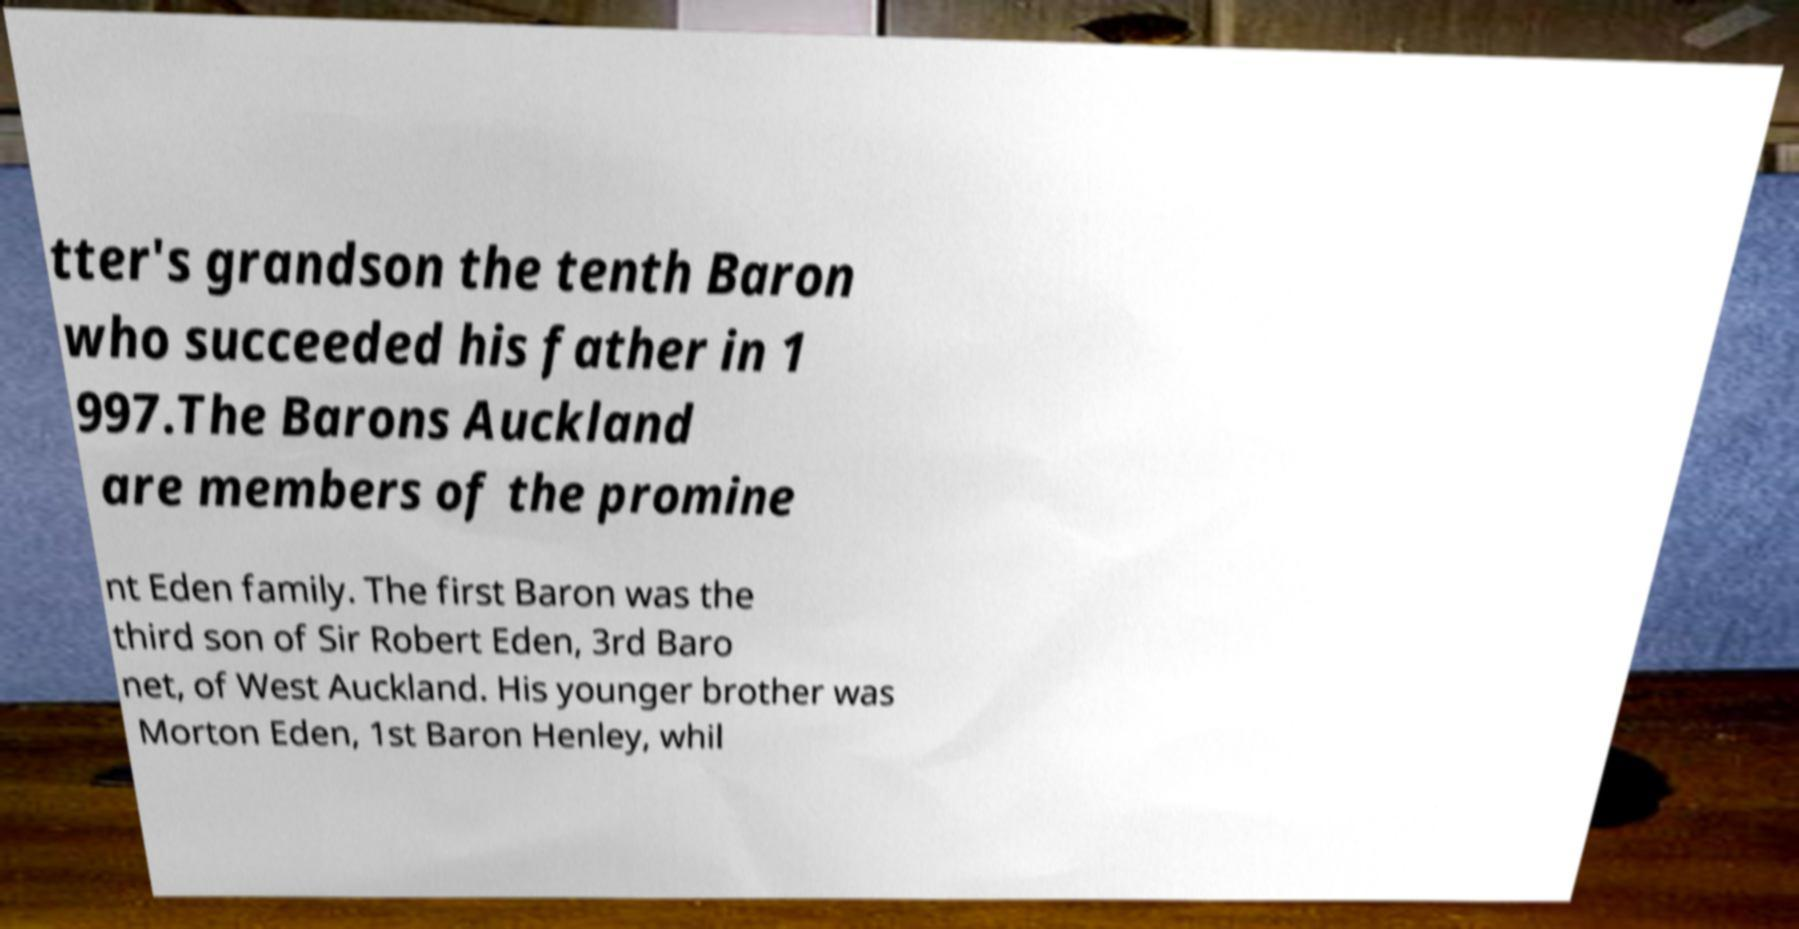Could you assist in decoding the text presented in this image and type it out clearly? tter's grandson the tenth Baron who succeeded his father in 1 997.The Barons Auckland are members of the promine nt Eden family. The first Baron was the third son of Sir Robert Eden, 3rd Baro net, of West Auckland. His younger brother was Morton Eden, 1st Baron Henley, whil 